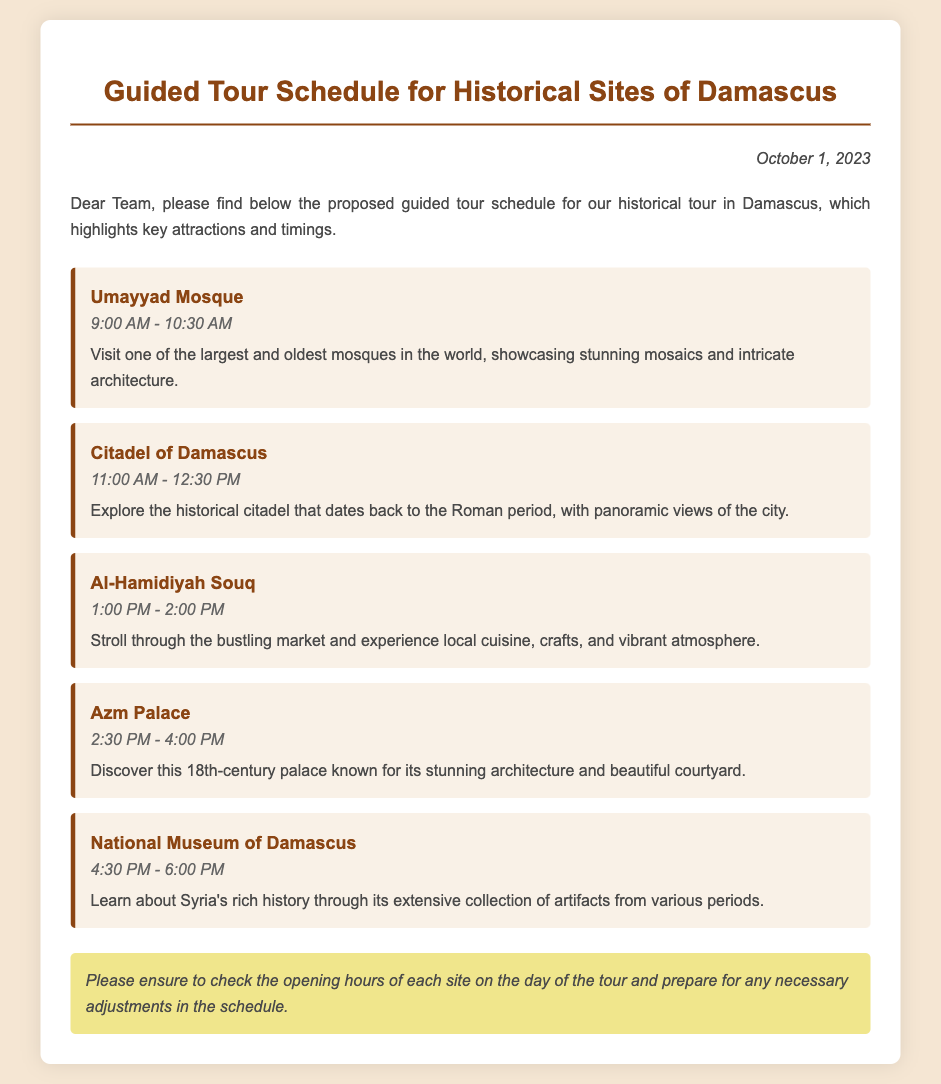What time does the tour of Umayyad Mosque start? The starting time of the Umayyad Mosque tour can be found in the schedule, which states it starts at 9:00 AM.
Answer: 9:00 AM What is the last attraction listed in the schedule? The last attraction in the document is the National Museum of Damascus, which is mentioned after Azm Palace.
Answer: National Museum of Damascus How long is the visit to Azm Palace? The duration of the visit to Azm Palace is provided in the schedule, which indicates it runs for 1.5 hours, from 2:30 PM to 4:00 PM.
Answer: 1.5 hours At what time does the tour of Al-Hamidiyah Souq begin? The starting time for the Al-Hamidiyah Souq visit is listed in the schedule as 1:00 PM.
Answer: 1:00 PM What is noted about checking the opening hours? A note in the document mentions checking the opening hours of each site on the day of the tour.
Answer: Check the opening hours Why is it important to prepare for adjustments in the schedule? The note at the end of the document suggests that adjustments may be necessary, implying potential changes in site availability or timing.
Answer: Necessary adjustments What period does the Citadel of Damascus date back to? The document mentions that the Citadel of Damascus dates back to the Roman period, which is included in its description.
Answer: Roman period 